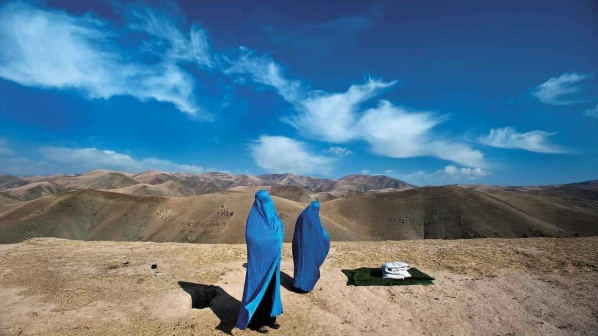Imagine what happens as the sun begins to set. As the sun began its descent, casting the sky in hues of orange and pink, the two women decided to set up a small camp. They placed the white and dark cloths to create a comfortable seating area. Noor, the black dog, sat upright, ears alert to the sounds of the evening. The air cooled, bringing a fresh breeze through the mountains.

With the panoramic view before them, they lit a small, safe fire to provide warmth as the night approached. The fire's glow danced on their blue burqas, making them appear like silhouettes against the vibrant backdrop of the setting sun. They shared a light meal and spoke of their journey's goals, aspirations, and the insights they'd already gathered. The serenity of the moment deepened with the descending darkness, stars beginning to dot the sky, and the sound of distant wildlife gently enveloping them.

This brief pause allowed them to reflect on the day's progress and prepare mentally and spiritually for the next steps of their adventure. As the last light of the sun dipped below the horizon, they shared a moment of silent prayer, feeling a deep connection to the natural world and the divine guidance they felt on their journey. 